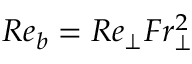Convert formula to latex. <formula><loc_0><loc_0><loc_500><loc_500>R e _ { b } = R e _ { \perp } F r _ { \perp } ^ { 2 }</formula> 